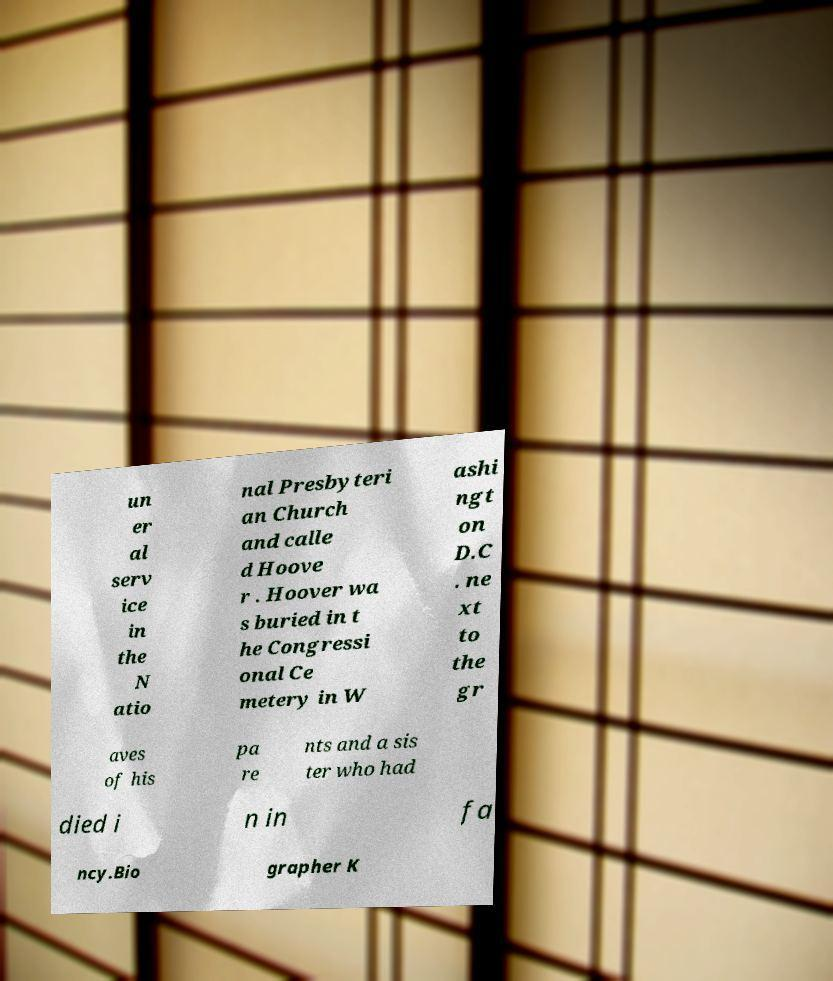What messages or text are displayed in this image? I need them in a readable, typed format. un er al serv ice in the N atio nal Presbyteri an Church and calle d Hoove r . Hoover wa s buried in t he Congressi onal Ce metery in W ashi ngt on D.C . ne xt to the gr aves of his pa re nts and a sis ter who had died i n in fa ncy.Bio grapher K 